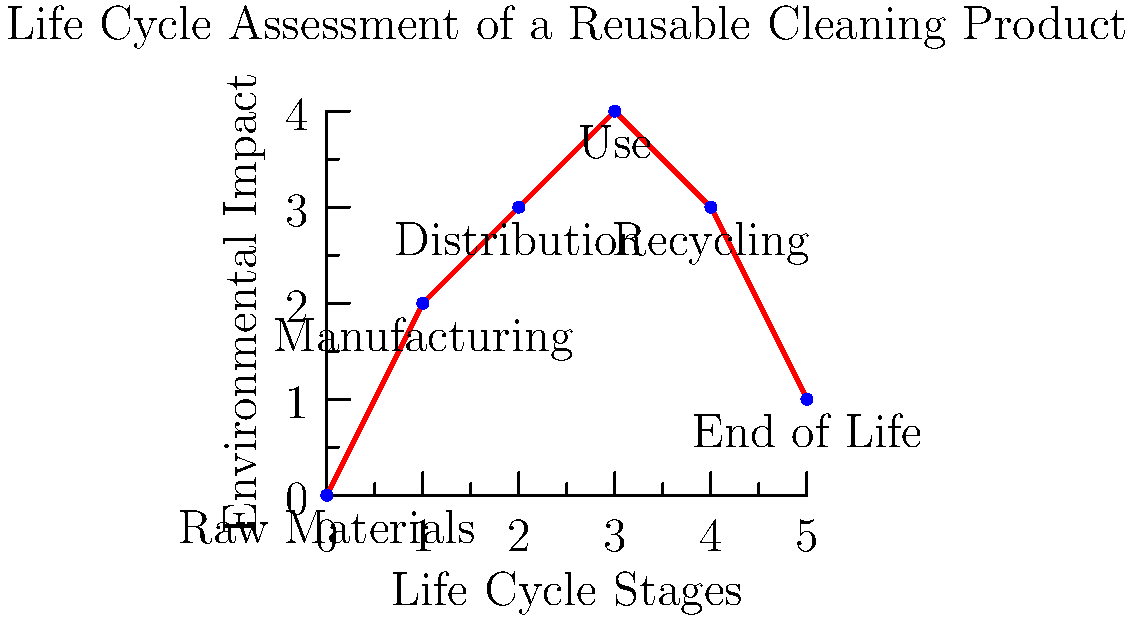Based on the life cycle assessment diagram for a reusable cleaning product, which stage appears to have the highest environmental impact, and how might this influence your product selection and distribution strategy as an eco-friendly packaging distributor? To answer this question, we need to analyze the diagram step-by-step:

1. The diagram shows the environmental impact of a reusable cleaning product across six life cycle stages.

2. The vertical axis represents the environmental impact, while the horizontal axis shows the different stages of the product's life cycle.

3. Examining the graph, we can see that the impact varies across stages:
   - Raw Materials: Low impact
   - Manufacturing: Moderate impact
   - Distribution: High impact
   - Use: Highest impact
   - Recycling: Moderate impact
   - End of Life: Low impact

4. The "Use" stage clearly has the highest peak on the graph, indicating the greatest environmental impact.

5. As an eco-friendly packaging distributor, this information is crucial because:
   a) It highlights the importance of focusing on products that have a lower environmental impact during use.
   b) It suggests that efforts to educate customers on efficient product use could significantly reduce overall environmental impact.
   c) It indicates that while distribution has a notable impact, improvements in product efficiency during use could yield greater environmental benefits.

6. This data could influence your strategy by:
   - Prioritizing products that are designed for efficient use and longevity
   - Developing educational materials for customers on best practices for product use
   - Exploring ways to reduce the environmental impact of the distribution stage, which has the second-highest impact

7. The high impact during the use phase might also suggest focusing on concentrated cleaning products or those that require less water or energy to use effectively.
Answer: Use stage; prioritize products with lower use-phase impact and educate customers on efficient usage. 